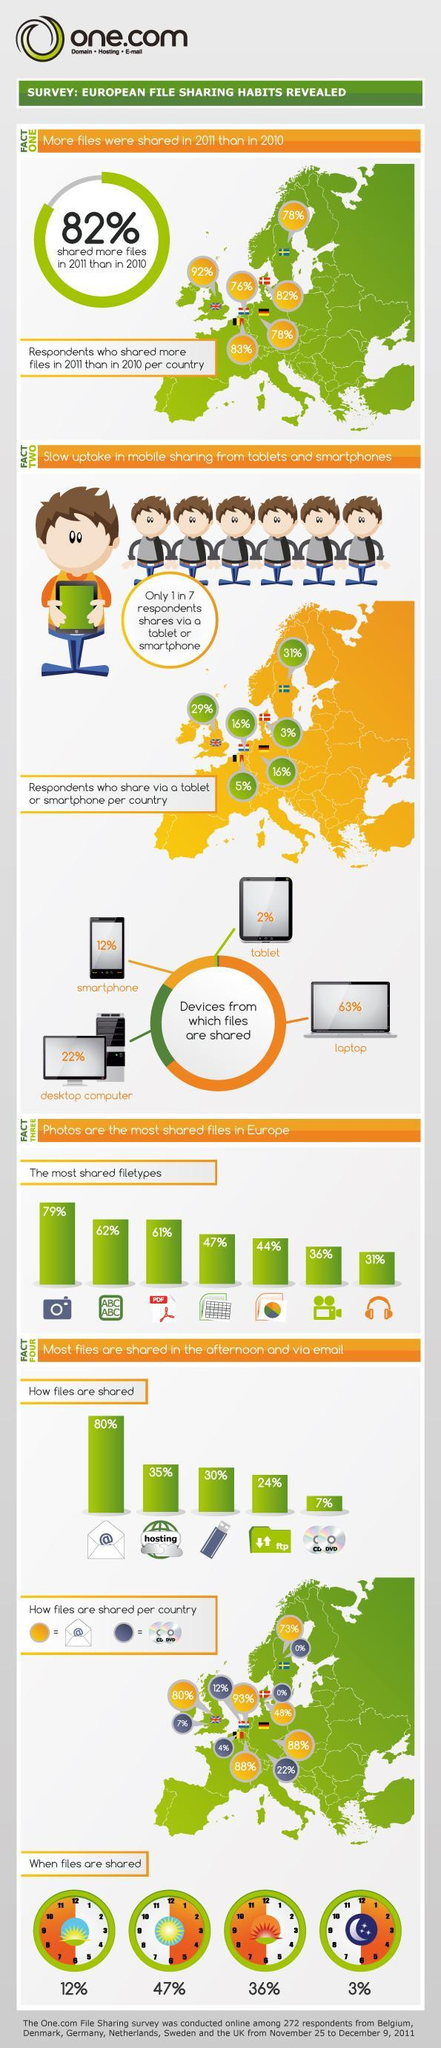When is the time files are shared the most - morning, afternoon, evening or night?
Answer the question with a short phrase. afternoon What is the percentage of respondents share data using tablets and smartphones combined? 14 How more files are shred - through ftp or cd / dvd? through ftp What is the percentage of respondents share data using laptops and desktops combined? 85 What is the least used tool to share files - ftp or cd/dvd? cd/dvd When is the time files are shared the least - morning, afternoon, evening or night? night What is the time percentage of files shared during evening time? 36% What is the percentage of respondents share data using laptops, smartphones and desktops combined? 98% What is the percentage of PDF files shared? 61% What is the percentage of respondents share using devices other than tablets/smartphones? 86% What is the second most used tool to share files? Hosting 